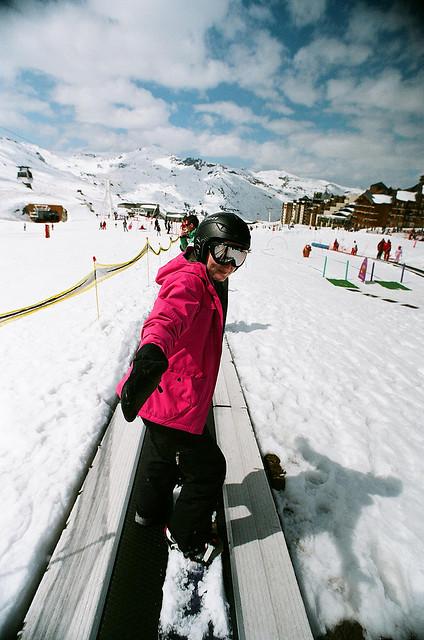Is this person moving?
Give a very brief answer. Yes. What color are the clouds?
Be succinct. White. What color is this woman's jacket?
Short answer required. Pink. What is she doing?
Short answer required. Skiing. 